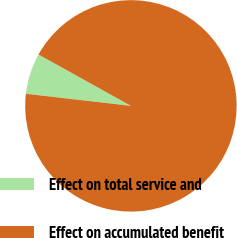<chart> <loc_0><loc_0><loc_500><loc_500><pie_chart><fcel>Effect on total service and<fcel>Effect on accumulated benefit<nl><fcel>6.25%<fcel>93.75%<nl></chart> 